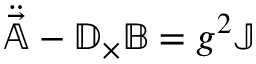Convert formula to latex. <formula><loc_0><loc_0><loc_500><loc_500>\ddot { \vec { \mathbb { A } } } - \mathbb { D } _ { \times } \mathbb { B } = g ^ { 2 } \mathbb { J }</formula> 